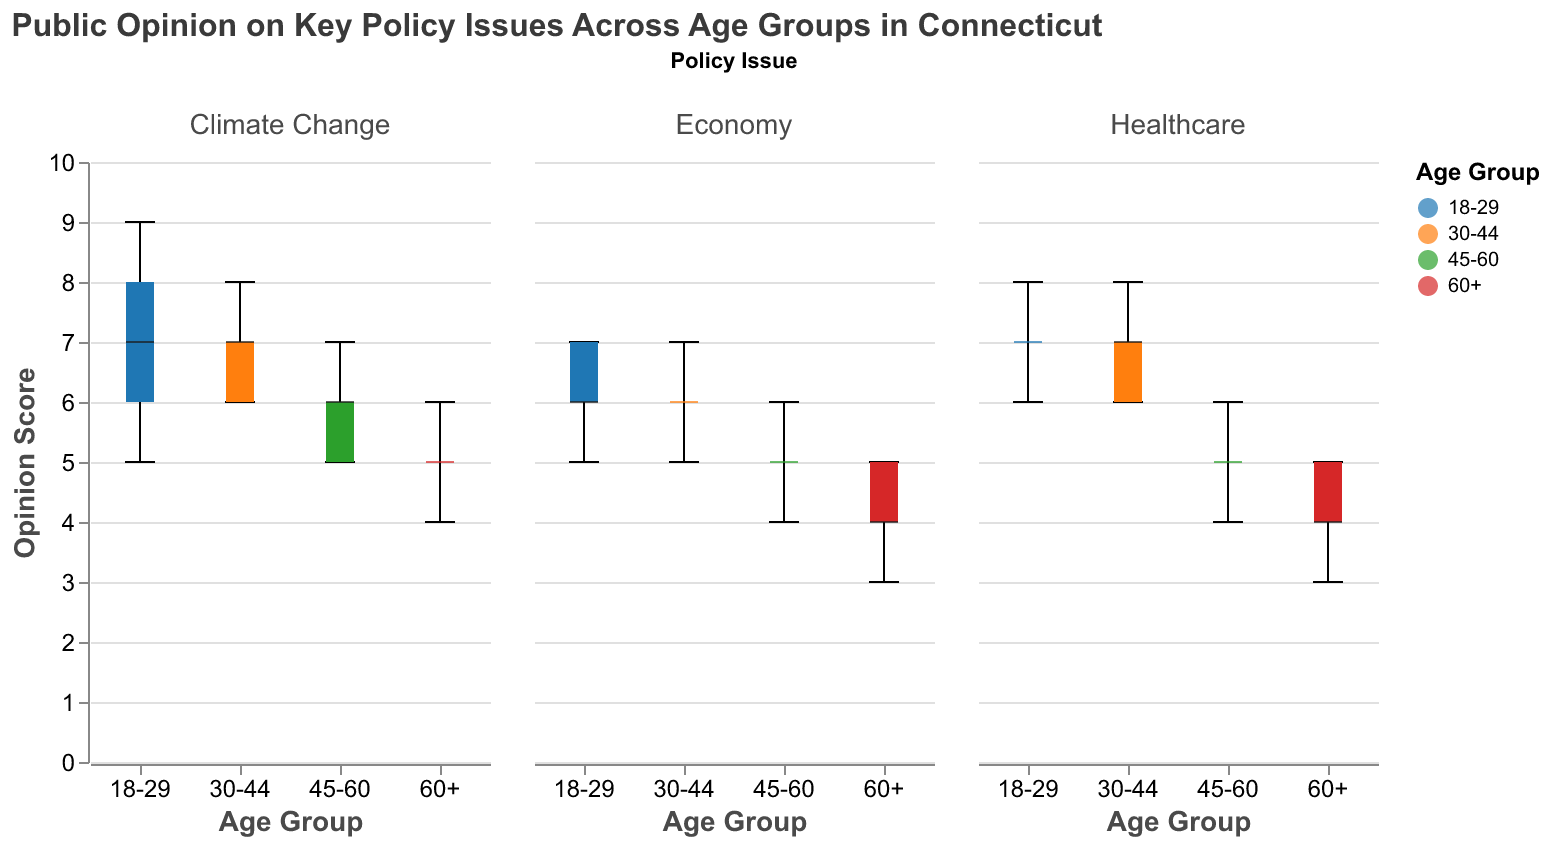What is the title of the figure? The title is positioned at the top of the figure. It indicates the main subject or focus of the chart. The title for this figure is given in the "title" field.
Answer: Public Opinion on Key Policy Issues Across Age Groups in Connecticut What are the four age groups shown in the figure? The age groups are displayed along the x-axes of the box plots. These groups are distinguished by different colors as well.
Answer: 18-29, 30-44, 45-60, 60+ Which age group has the highest median opinion score for Climate Change? To answer this, look for the line within each box plot under the “Climate Change” subplot. Compare the heights of these median lines across the age groups.
Answer: 18-29 How does the median opinion score for Healthcare compare between the 18-29 and 60+ age groups? Compare the lines within the box plots under the “Healthcare” subplot for the 18-29 and 60+ age groups. The median line in the box plot indicates the median score.
Answer: Higher for 18-29 What is the range of opinion scores for the 45-60 age group on the Economy? The range is determined by the minimum and maximum whiskers of the box plot for the 45-60 age group under the “Economy” subplot.
Answer: 4 to 6 Which policy issue shows the largest difference in median opinion scores between the youngest and oldest age groups? Compare the differences between the medians in the “18-29” and “60+” age groups across all three policy issues. The policy issue with the largest difference is the one that stands out the most.
Answer: Climate Change What is the interquartile range (IQR) for the opinion scores of the 30-44 age group on Healthcare? The IQR is the range between the first quartile (Q1) and the third quartile (Q3) of a box plot. In the “Healthcare” subplot, measure the distance between the bottom and top of the box for the 30-44 age group.
Answer: 6 to 7 How many total opinion scores are plotted for the 60+ age group on all policy issues combined? Count the number of data points within each box plot under the “60+” age group across all three subplots and sum them up.
Answer: 15 Which age group shows the least variation in their opinion scores for Climate Change? The least variation can be identified by finding the shortest box plot (smallest IQR) and shortest whiskers under the “Climate Change” subplot.
Answer: 60+ For which policy issue do the 45-60 age group have the closest median opinion score to the 60+ age group? Compare the median lines for the 45-60 and 60+ age groups across all three policy issues. Identify the policy where the median lines are closest.
Answer: Healthcare 